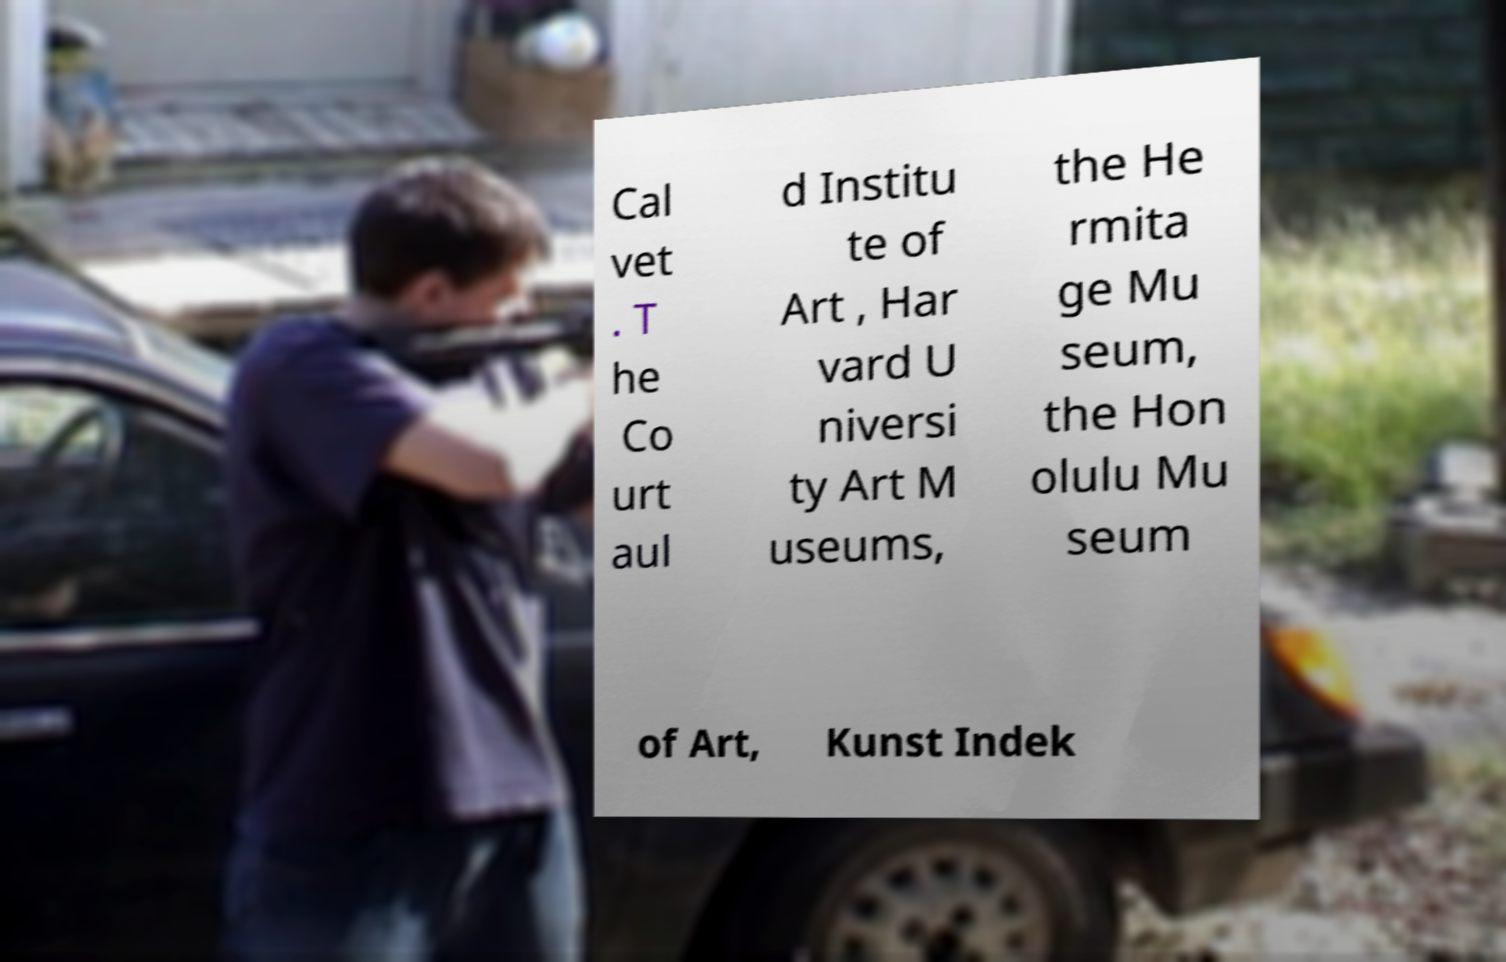I need the written content from this picture converted into text. Can you do that? Cal vet . T he Co urt aul d Institu te of Art , Har vard U niversi ty Art M useums, the He rmita ge Mu seum, the Hon olulu Mu seum of Art, Kunst Indek 